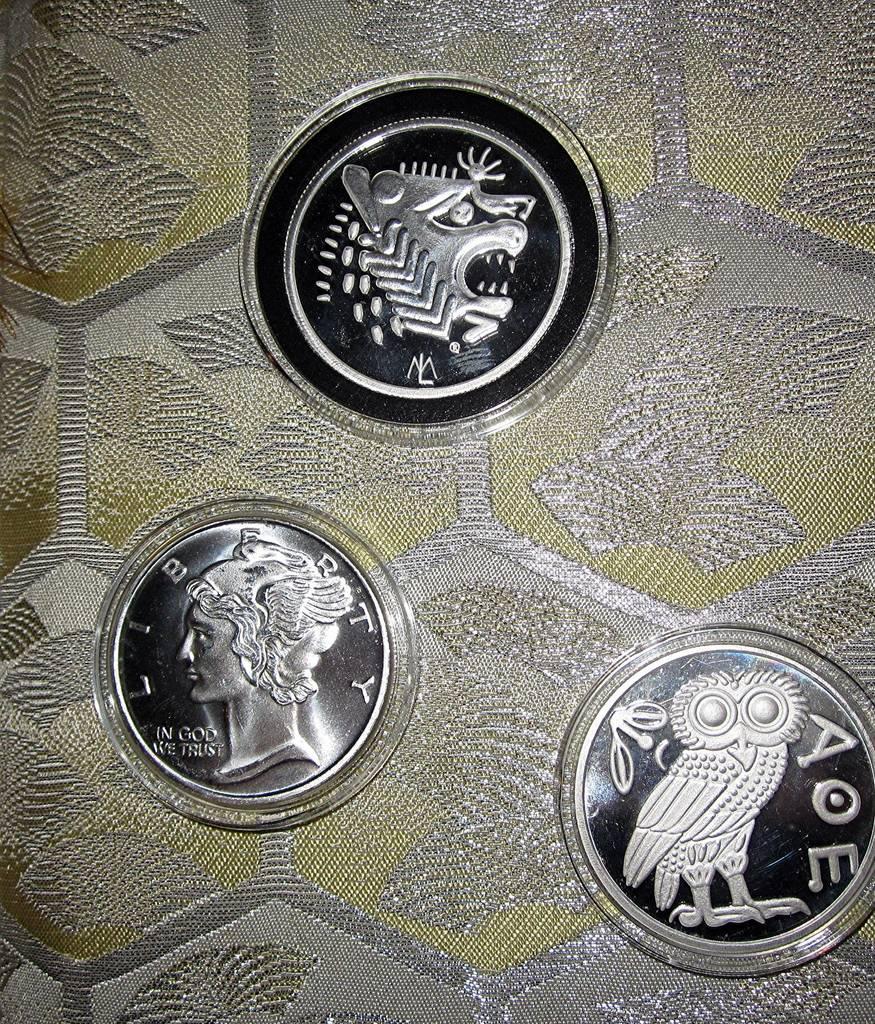How would you summarize this image in a sentence or two? This picture shows coins on the table. 